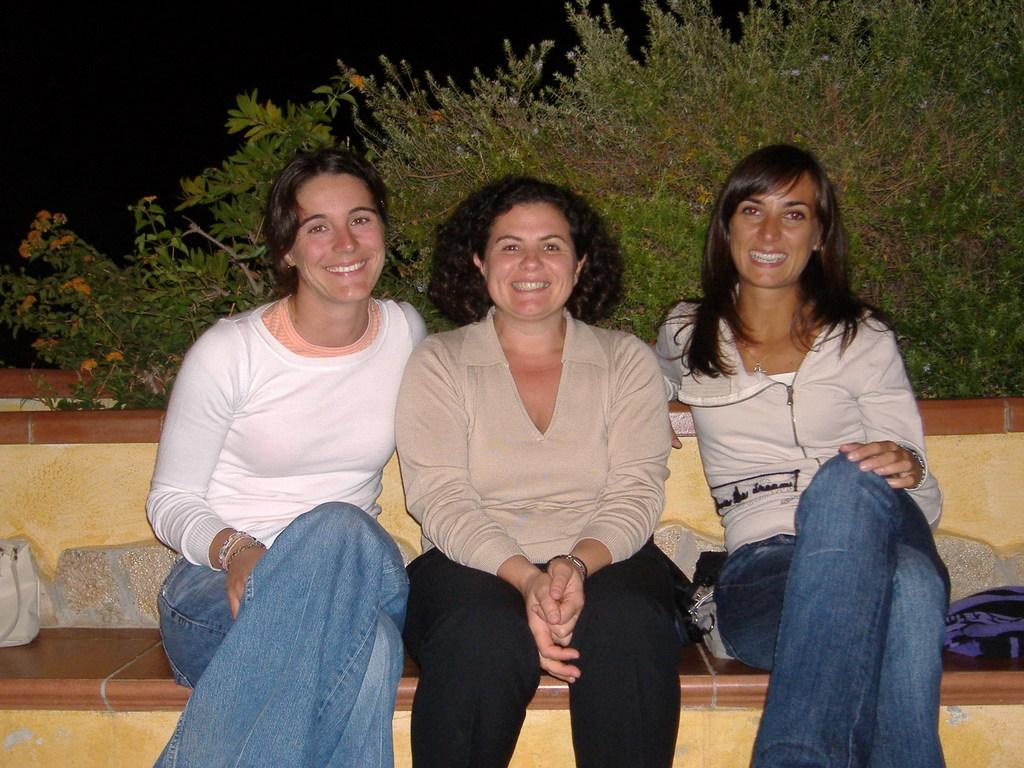Who is present in the image? There are people in the image. What are the people doing in the image? The people are sitting. What expression do the people have in the image? The people are smiling. What can be seen in the background of the image? There are plants in the background of the image. What type of instrument are the sisters playing in the image? There is no mention of an instrument or sisters in the image, so it cannot be determined what type of instrument they might be playing. 